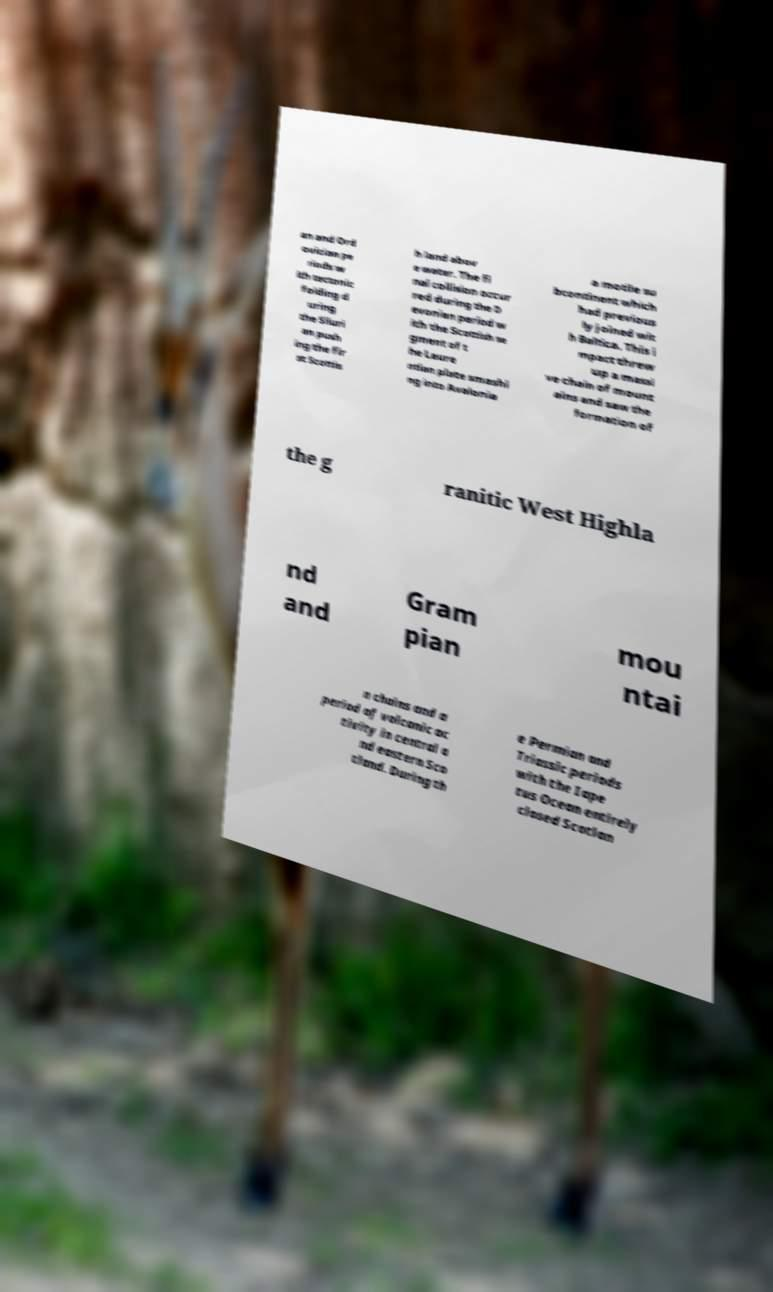Please identify and transcribe the text found in this image. an and Ord ovician pe riods w ith tectonic folding d uring the Siluri an push ing the fir st Scottis h land abov e water. The fi nal collision occur red during the D evonian period w ith the Scottish se gment of t he Laure ntian plate smashi ng into Avalonia a motile su bcontinent which had previous ly joined wit h Baltica. This i mpact threw up a massi ve chain of mount ains and saw the formation of the g ranitic West Highla nd and Gram pian mou ntai n chains and a period of volcanic ac tivity in central a nd eastern Sco tland. During th e Permian and Triassic periods with the Iape tus Ocean entirely closed Scotlan 